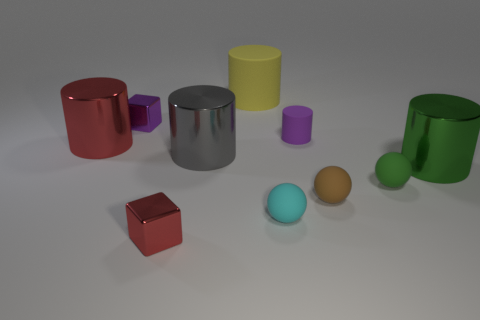Subtract all small brown rubber balls. How many balls are left? 2 Subtract all red cylinders. How many cylinders are left? 4 Subtract all blocks. How many objects are left? 8 Subtract 1 spheres. How many spheres are left? 2 Subtract all cyan cylinders. Subtract all red blocks. How many cylinders are left? 5 Subtract all purple things. Subtract all tiny cyan rubber blocks. How many objects are left? 8 Add 9 green cylinders. How many green cylinders are left? 10 Add 6 large yellow rubber things. How many large yellow rubber things exist? 7 Subtract 0 cyan cylinders. How many objects are left? 10 